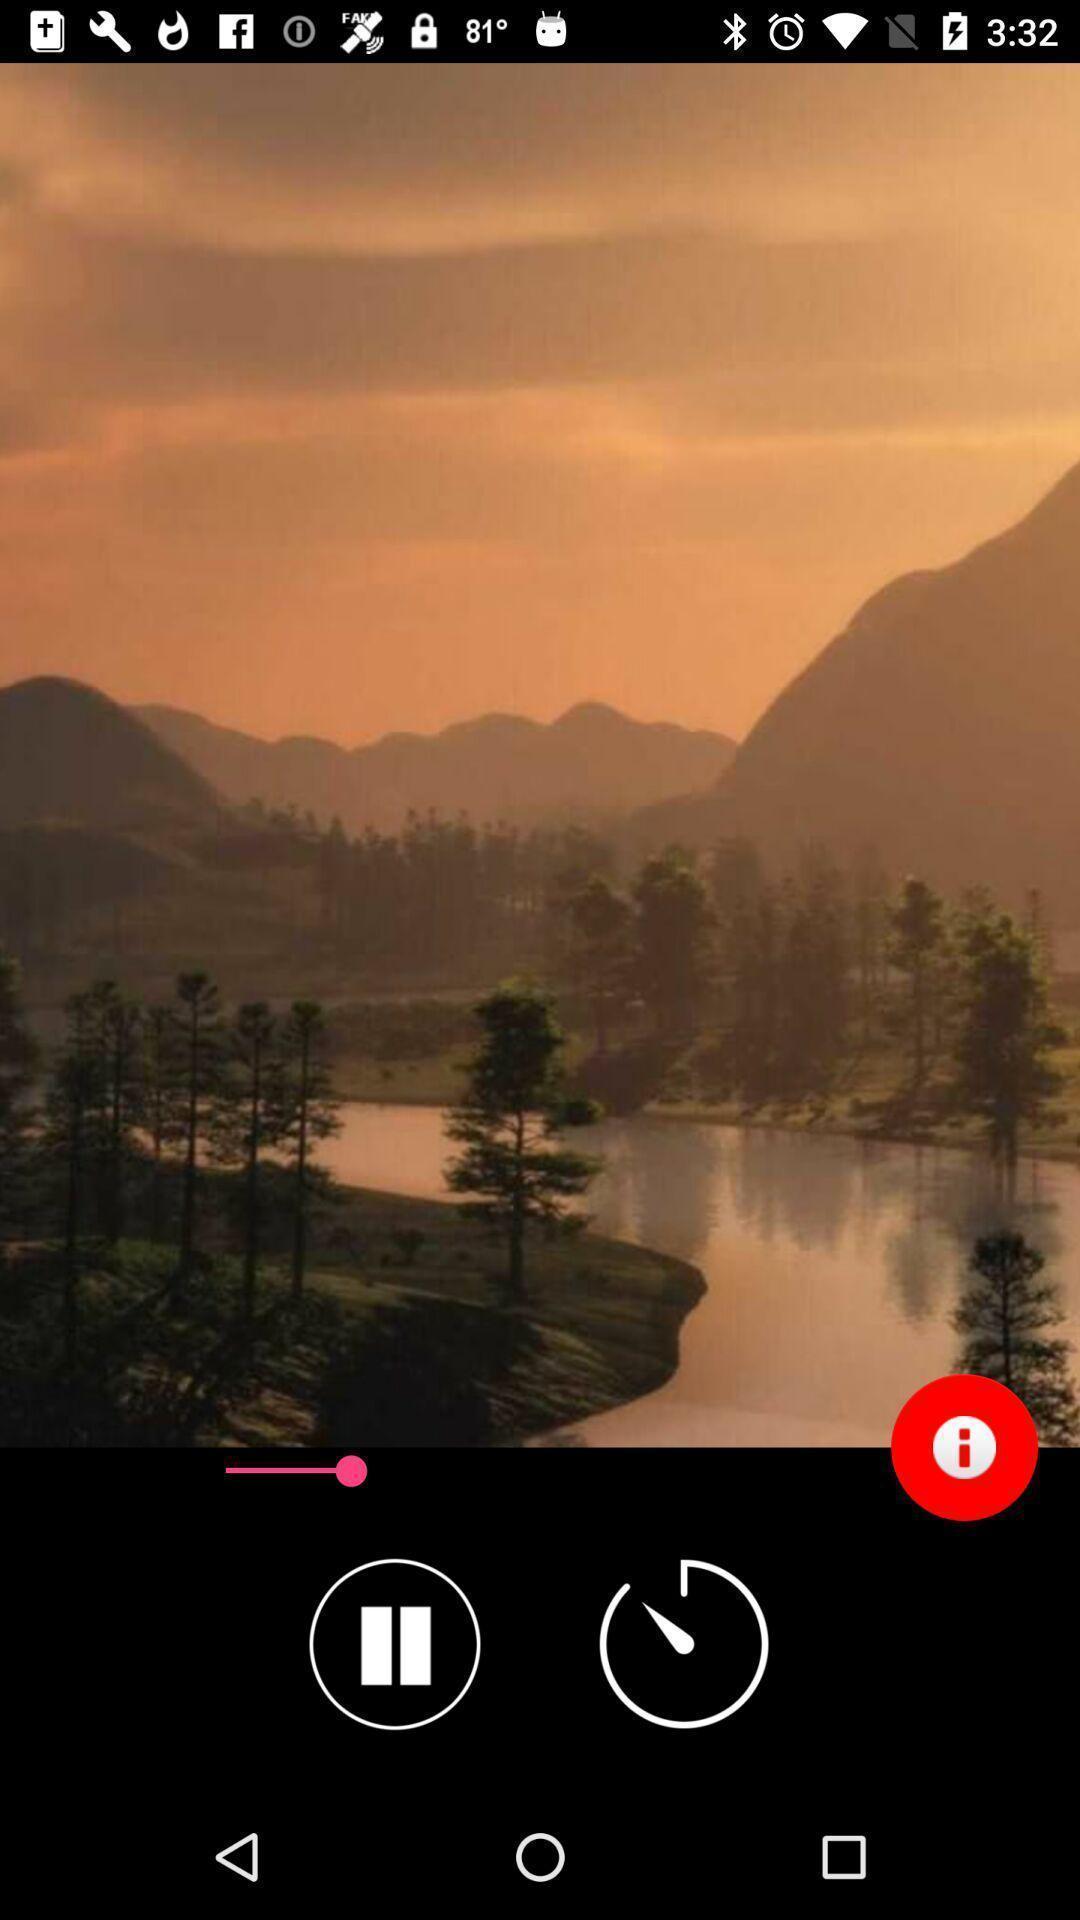What is the overall content of this screenshot? Page showing the tacker of audio app. 